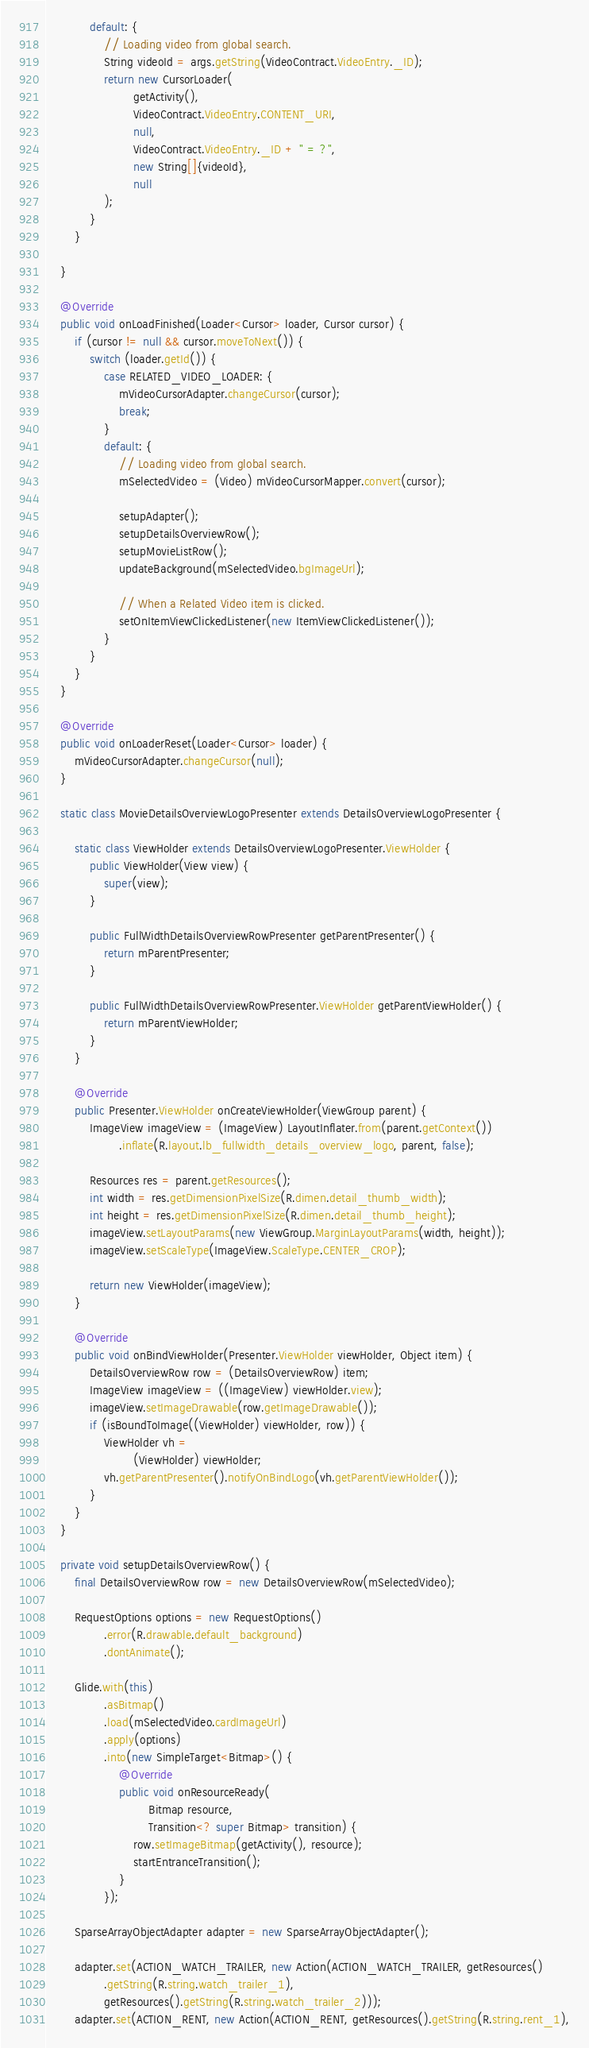Convert code to text. <code><loc_0><loc_0><loc_500><loc_500><_Java_>            default: {
                // Loading video from global search.
                String videoId = args.getString(VideoContract.VideoEntry._ID);
                return new CursorLoader(
                        getActivity(),
                        VideoContract.VideoEntry.CONTENT_URI,
                        null,
                        VideoContract.VideoEntry._ID + " = ?",
                        new String[]{videoId},
                        null
                );
            }
        }

    }

    @Override
    public void onLoadFinished(Loader<Cursor> loader, Cursor cursor) {
        if (cursor != null && cursor.moveToNext()) {
            switch (loader.getId()) {
                case RELATED_VIDEO_LOADER: {
                    mVideoCursorAdapter.changeCursor(cursor);
                    break;
                }
                default: {
                    // Loading video from global search.
                    mSelectedVideo = (Video) mVideoCursorMapper.convert(cursor);

                    setupAdapter();
                    setupDetailsOverviewRow();
                    setupMovieListRow();
                    updateBackground(mSelectedVideo.bgImageUrl);

                    // When a Related Video item is clicked.
                    setOnItemViewClickedListener(new ItemViewClickedListener());
                }
            }
        }
    }

    @Override
    public void onLoaderReset(Loader<Cursor> loader) {
        mVideoCursorAdapter.changeCursor(null);
    }

    static class MovieDetailsOverviewLogoPresenter extends DetailsOverviewLogoPresenter {

        static class ViewHolder extends DetailsOverviewLogoPresenter.ViewHolder {
            public ViewHolder(View view) {
                super(view);
            }

            public FullWidthDetailsOverviewRowPresenter getParentPresenter() {
                return mParentPresenter;
            }

            public FullWidthDetailsOverviewRowPresenter.ViewHolder getParentViewHolder() {
                return mParentViewHolder;
            }
        }

        @Override
        public Presenter.ViewHolder onCreateViewHolder(ViewGroup parent) {
            ImageView imageView = (ImageView) LayoutInflater.from(parent.getContext())
                    .inflate(R.layout.lb_fullwidth_details_overview_logo, parent, false);

            Resources res = parent.getResources();
            int width = res.getDimensionPixelSize(R.dimen.detail_thumb_width);
            int height = res.getDimensionPixelSize(R.dimen.detail_thumb_height);
            imageView.setLayoutParams(new ViewGroup.MarginLayoutParams(width, height));
            imageView.setScaleType(ImageView.ScaleType.CENTER_CROP);

            return new ViewHolder(imageView);
        }

        @Override
        public void onBindViewHolder(Presenter.ViewHolder viewHolder, Object item) {
            DetailsOverviewRow row = (DetailsOverviewRow) item;
            ImageView imageView = ((ImageView) viewHolder.view);
            imageView.setImageDrawable(row.getImageDrawable());
            if (isBoundToImage((ViewHolder) viewHolder, row)) {
                ViewHolder vh =
                        (ViewHolder) viewHolder;
                vh.getParentPresenter().notifyOnBindLogo(vh.getParentViewHolder());
            }
        }
    }

    private void setupDetailsOverviewRow() {
        final DetailsOverviewRow row = new DetailsOverviewRow(mSelectedVideo);

        RequestOptions options = new RequestOptions()
                .error(R.drawable.default_background)
                .dontAnimate();

        Glide.with(this)
                .asBitmap()
                .load(mSelectedVideo.cardImageUrl)
                .apply(options)
                .into(new SimpleTarget<Bitmap>() {
                    @Override
                    public void onResourceReady(
                            Bitmap resource,
                            Transition<? super Bitmap> transition) {
                        row.setImageBitmap(getActivity(), resource);
                        startEntranceTransition();
                    }
                });

        SparseArrayObjectAdapter adapter = new SparseArrayObjectAdapter();

        adapter.set(ACTION_WATCH_TRAILER, new Action(ACTION_WATCH_TRAILER, getResources()
                .getString(R.string.watch_trailer_1),
                getResources().getString(R.string.watch_trailer_2)));
        adapter.set(ACTION_RENT, new Action(ACTION_RENT, getResources().getString(R.string.rent_1),</code> 